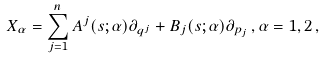Convert formula to latex. <formula><loc_0><loc_0><loc_500><loc_500>X _ { \alpha } = \sum _ { j = 1 } ^ { n } A ^ { j } ( s ; \alpha ) \partial _ { q ^ { j } } + B _ { j } ( s ; \alpha ) \partial _ { p _ { j } } \, , \alpha = 1 , 2 \, ,</formula> 